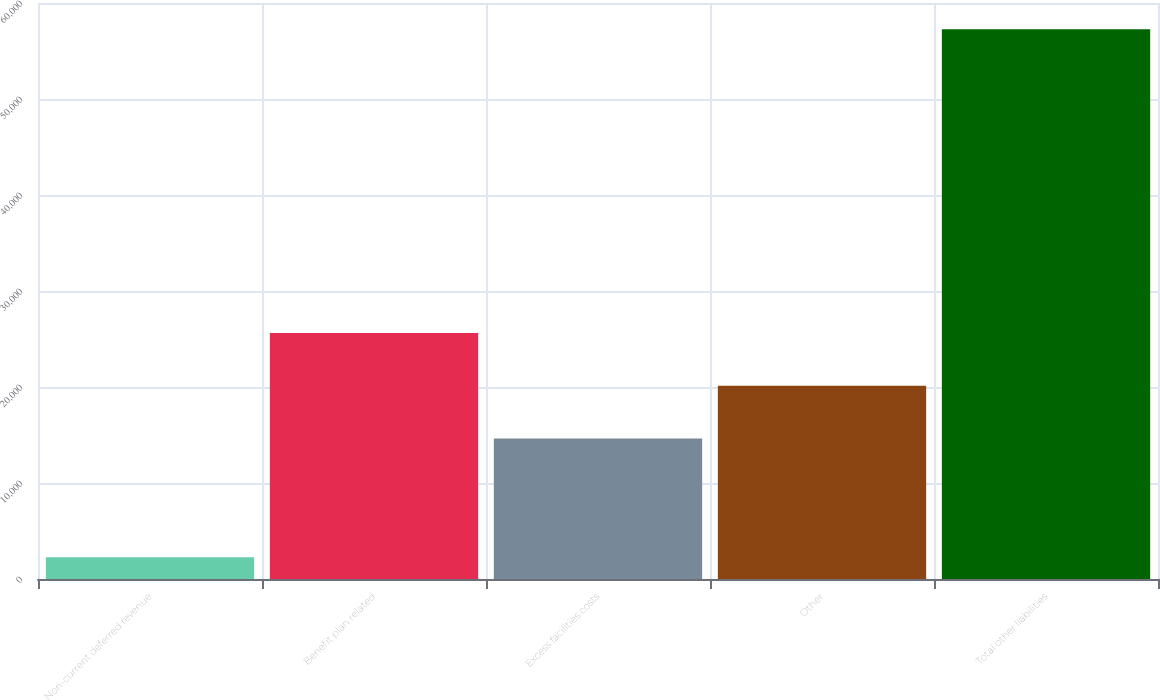Convert chart to OTSL. <chart><loc_0><loc_0><loc_500><loc_500><bar_chart><fcel>Non-current deferred revenue<fcel>Benefit plan related<fcel>Excess facilities costs<fcel>Other<fcel>Total other liabilities<nl><fcel>2277<fcel>25633.8<fcel>14637<fcel>20135.4<fcel>57261<nl></chart> 